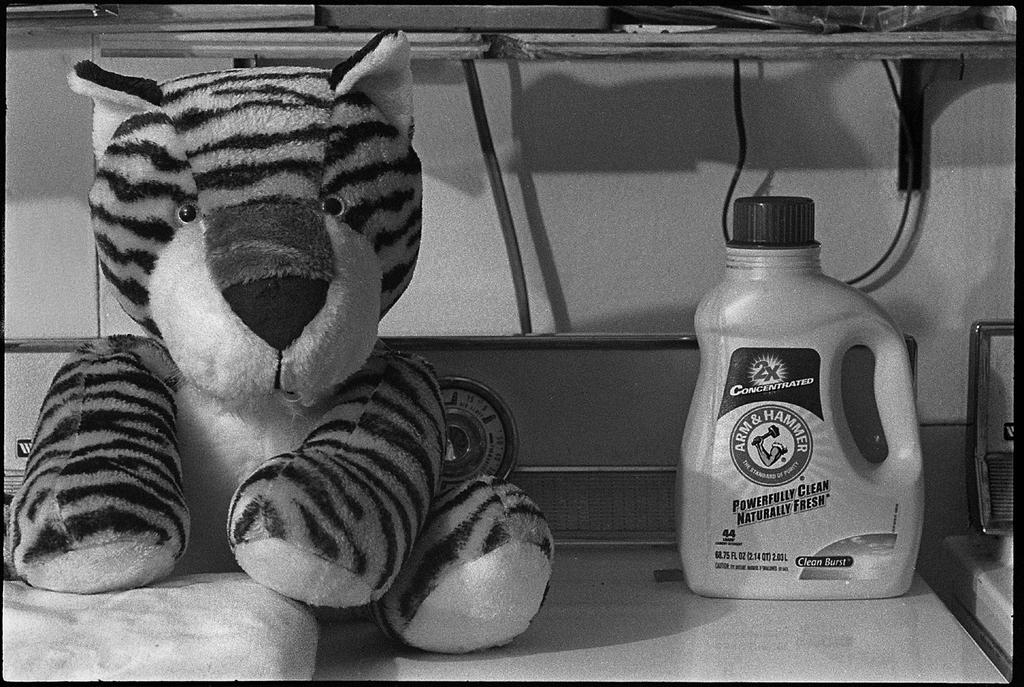What type of toy is present in the image? There is a toy tiger in the image. What other object can be seen in the image? There is a can in the image. What can be seen in the background of the image? Wires, a rack, and a plastic cover are visible in the background of the image. What type of writing can be seen on the can in the image? There is no writing visible on the can in the image. Where is the vacation destination mentioned in the image? There is no mention of a vacation destination in the image. 